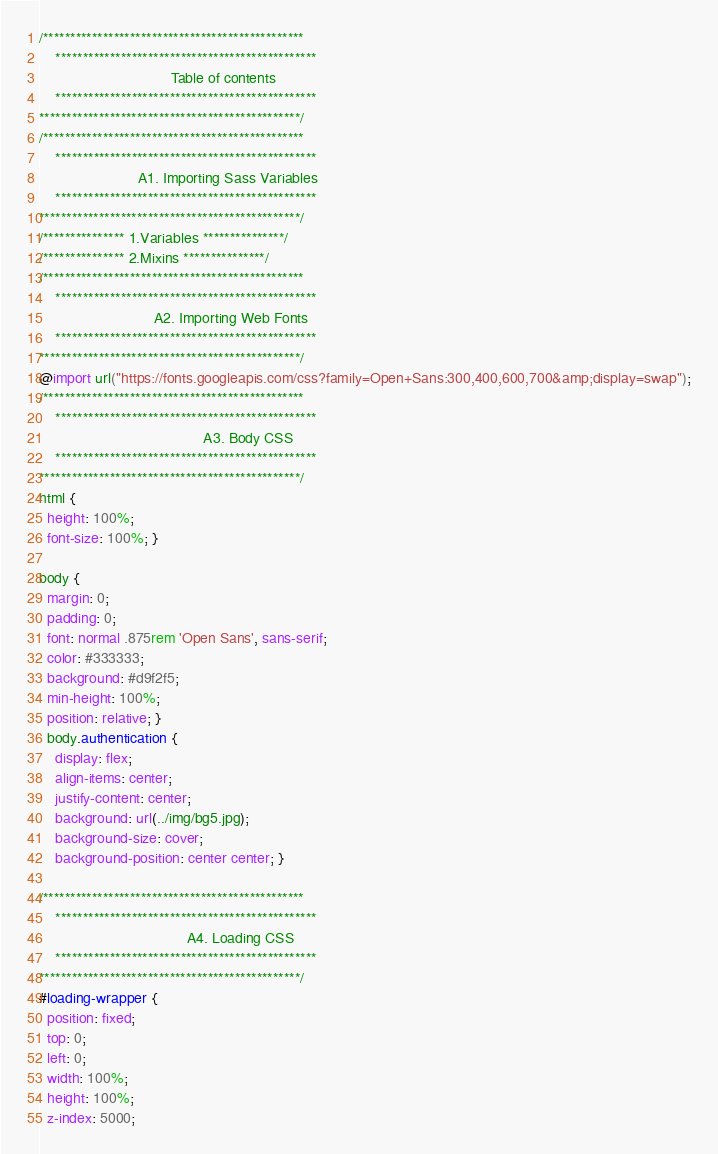<code> <loc_0><loc_0><loc_500><loc_500><_CSS_>/************************************************
	************************************************
								Table of contents
	************************************************
************************************************/
/************************************************
	************************************************
						A1. Importing Sass Variables
	************************************************
************************************************/
/*************** 1.Variables ***************/
/*************** 2.Mixins ***************/
/************************************************
	************************************************
							A2. Importing Web Fonts
	************************************************
************************************************/
@import url("https://fonts.googleapis.com/css?family=Open+Sans:300,400,600,700&amp;display=swap");
/************************************************
	************************************************
										A3. Body CSS
	************************************************
************************************************/
html {
  height: 100%;
  font-size: 100%; }

body {
  margin: 0;
  padding: 0;
  font: normal .875rem 'Open Sans', sans-serif;
  color: #333333;
  background: #d9f2f5;
  min-height: 100%;
  position: relative; }
  body.authentication {
    display: flex;
    align-items: center;
    justify-content: center;
    background: url(../img/bg5.jpg);
    background-size: cover;
    background-position: center center; }

/************************************************
	************************************************
									A4. Loading CSS
	************************************************
************************************************/
#loading-wrapper {
  position: fixed;
  top: 0;
  left: 0;
  width: 100%;
  height: 100%;
  z-index: 5000;</code> 